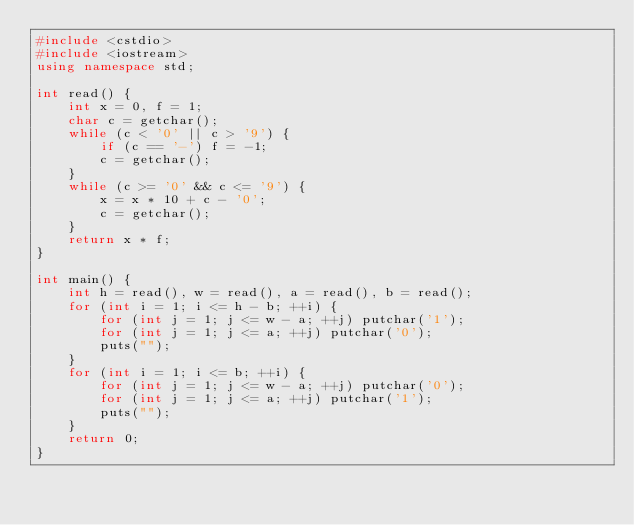Convert code to text. <code><loc_0><loc_0><loc_500><loc_500><_C++_>#include <cstdio>
#include <iostream>
using namespace std;

int read() {
    int x = 0, f = 1;
    char c = getchar();
    while (c < '0' || c > '9') {
        if (c == '-') f = -1;
        c = getchar();
    }
    while (c >= '0' && c <= '9') {
        x = x * 10 + c - '0';
        c = getchar();
    }
    return x * f;
}

int main() {
    int h = read(), w = read(), a = read(), b = read();
    for (int i = 1; i <= h - b; ++i) {
        for (int j = 1; j <= w - a; ++j) putchar('1');
        for (int j = 1; j <= a; ++j) putchar('0');
        puts("");
    }
    for (int i = 1; i <= b; ++i) {
        for (int j = 1; j <= w - a; ++j) putchar('0');
        for (int j = 1; j <= a; ++j) putchar('1');
        puts("");
    }
    return 0;
}</code> 